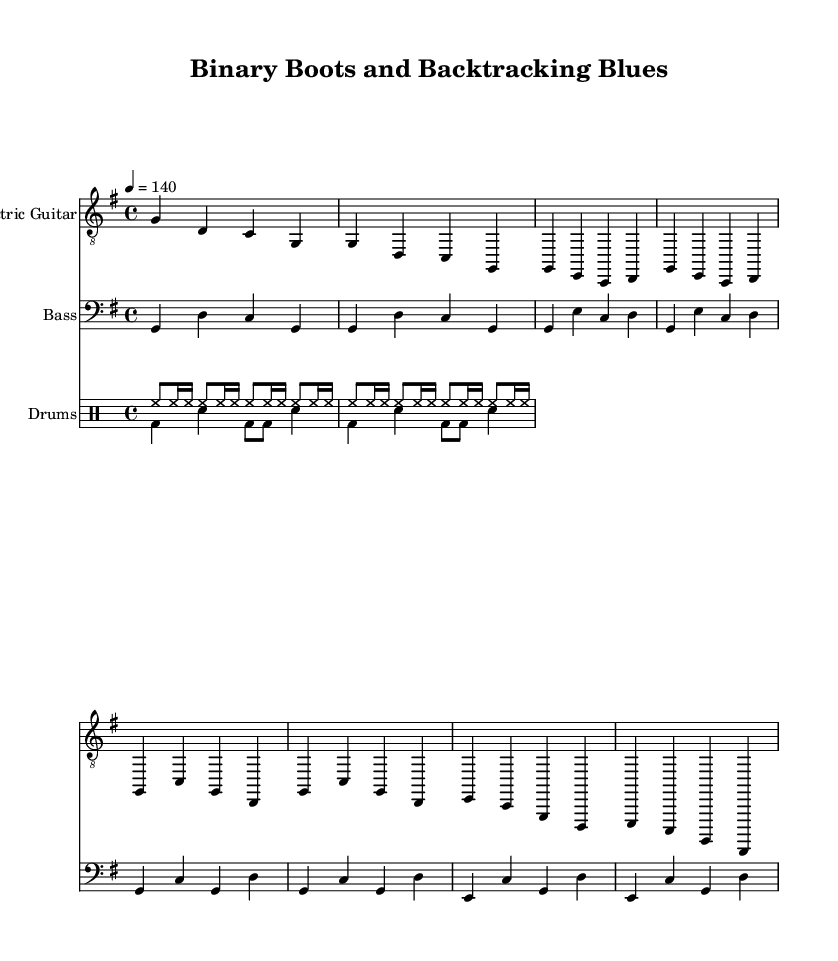What is the key signature of this music? The key signature is G major, indicated by one sharp (F#) in the key signature section at the beginning of the score.
Answer: G major What is the time signature of the piece? The time signature is 4/4, which is typically indicated near the beginning of the score and denotes four beats in a measure.
Answer: 4/4 What is the tempo marking for this piece? The tempo marking is given as 4 = 140, meaning that there are 140 beats per minute, with a quarter note getting the beat.
Answer: 140 What instrument is used for the vocal lyrics? The vocal lyrics are set to the electric guitar part, as indicated in the Lyrics section tied to "electricGuitar."
Answer: Electric Guitar How many distinct sections are indicated in the lyrics? There are two distinct sections indicated in the lyrics: Verse and Chorus, as labeled in the lyrics stanza settings within the score.
Answer: 2 What type of beat is incorporated into the drums? The drums incorporate a basic rock beat complemented by a country shuffle on the hi-hat, which is characteristic of the country rock genre.
Answer: Country shuffle What is the thematic focus of the lyrics in this piece? The thematic focus of the lyrics is on debugging and solving puzzles, as specified in the expression of the content found in the verses and chorus.
Answer: Debugging 